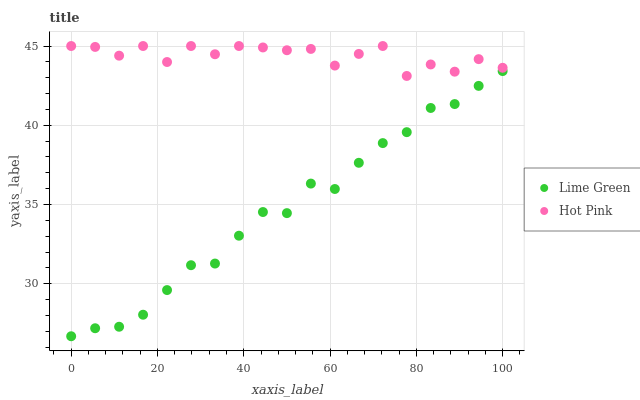Does Lime Green have the minimum area under the curve?
Answer yes or no. Yes. Does Hot Pink have the maximum area under the curve?
Answer yes or no. Yes. Does Lime Green have the maximum area under the curve?
Answer yes or no. No. Is Lime Green the smoothest?
Answer yes or no. Yes. Is Hot Pink the roughest?
Answer yes or no. Yes. Is Lime Green the roughest?
Answer yes or no. No. Does Lime Green have the lowest value?
Answer yes or no. Yes. Does Hot Pink have the highest value?
Answer yes or no. Yes. Does Lime Green have the highest value?
Answer yes or no. No. Is Lime Green less than Hot Pink?
Answer yes or no. Yes. Is Hot Pink greater than Lime Green?
Answer yes or no. Yes. Does Lime Green intersect Hot Pink?
Answer yes or no. No. 